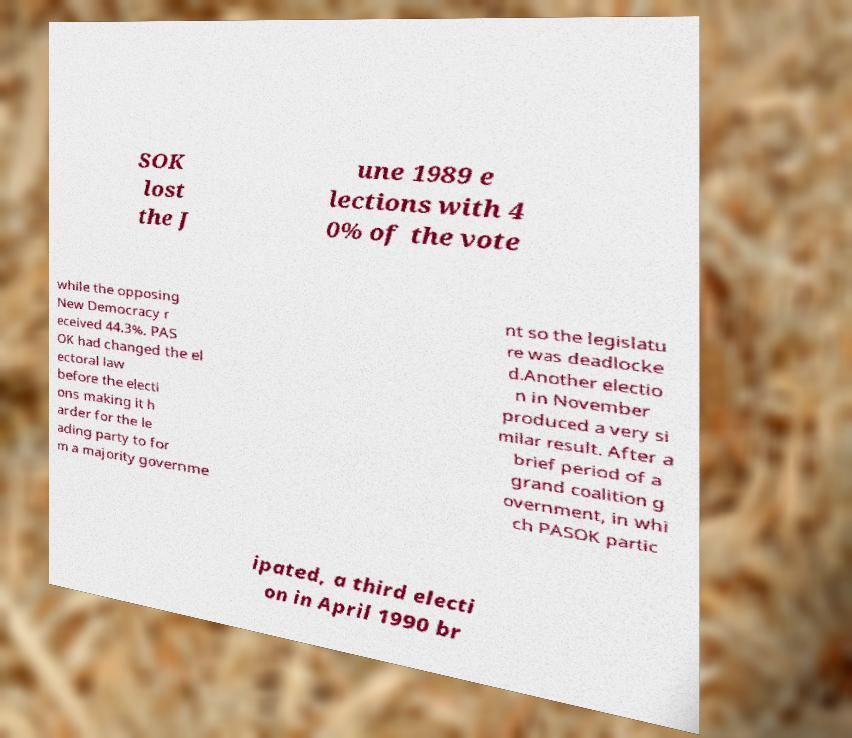Could you assist in decoding the text presented in this image and type it out clearly? SOK lost the J une 1989 e lections with 4 0% of the vote while the opposing New Democracy r eceived 44.3%. PAS OK had changed the el ectoral law before the electi ons making it h arder for the le ading party to for m a majority governme nt so the legislatu re was deadlocke d.Another electio n in November produced a very si milar result. After a brief period of a grand coalition g overnment, in whi ch PASOK partic ipated, a third electi on in April 1990 br 